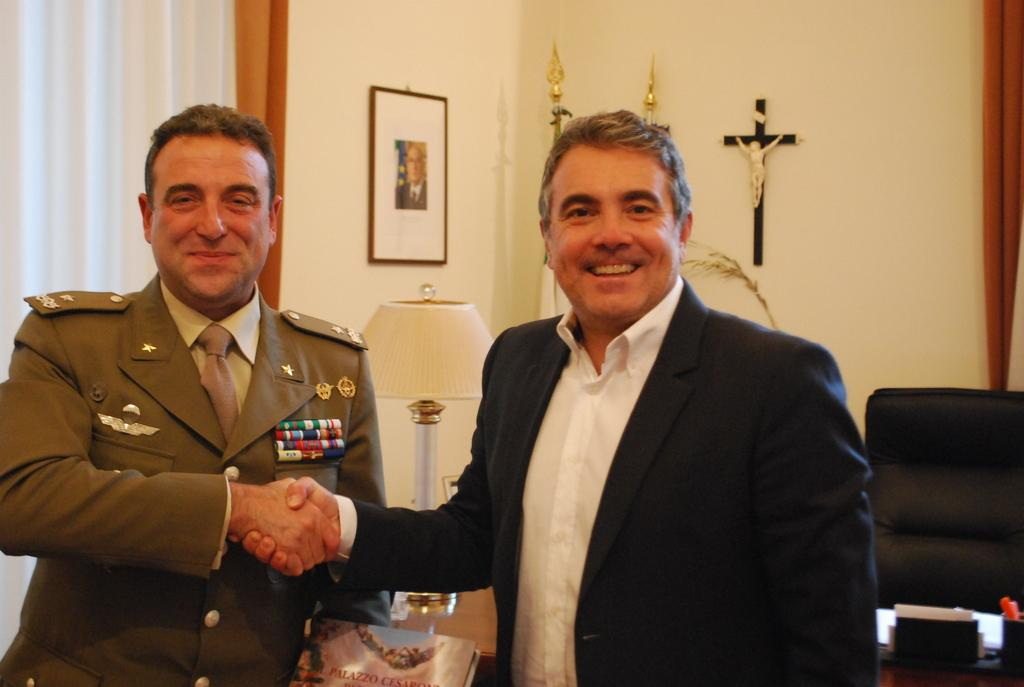How many people are in the image? There are two men in the image. What are the men doing in the image? The men are greeting each other and laughing. What can be seen in the background of the image? There is a chair, a light, and a photo frame in the background of the image. What type of mark can be seen on the men's faces in the image? There are no visible marks on the men's faces in the image. How many times do the men rest during their interaction in the image? The men are not shown resting in the image; they are actively greeting and laughing. 